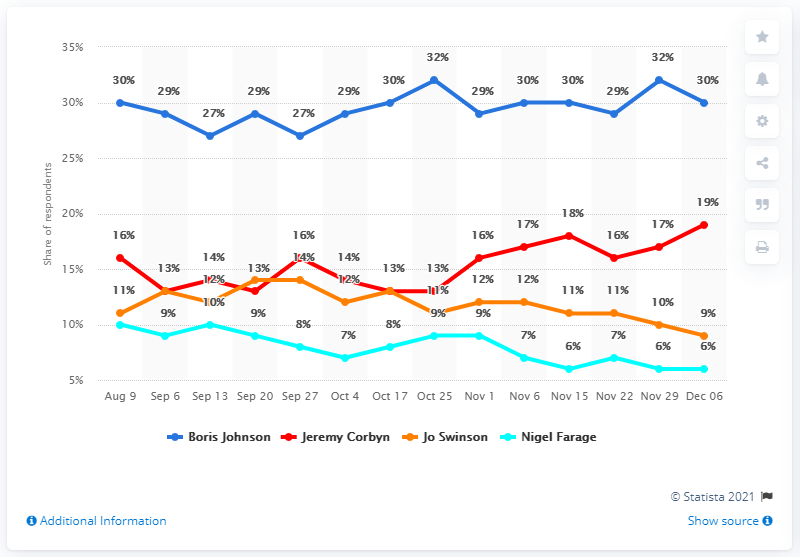Highlight a few significant elements in this photo. According to a survey conducted among 30% of Britons, Boris Johnson was considered the best candidate for Prime Minister by a significant amount. Boris Johnson's closest rival in the 2020 UK general election was Jeremy Corbyn. Thirty percent of the respondents believed that Boris Johnson would be the best prime minister as of November 6. The chart shows the highest and lowest share of respondents who support Boris Johnson, with 5% of respondents indicating their strongest support for Johnson. 